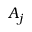<formula> <loc_0><loc_0><loc_500><loc_500>A _ { j }</formula> 